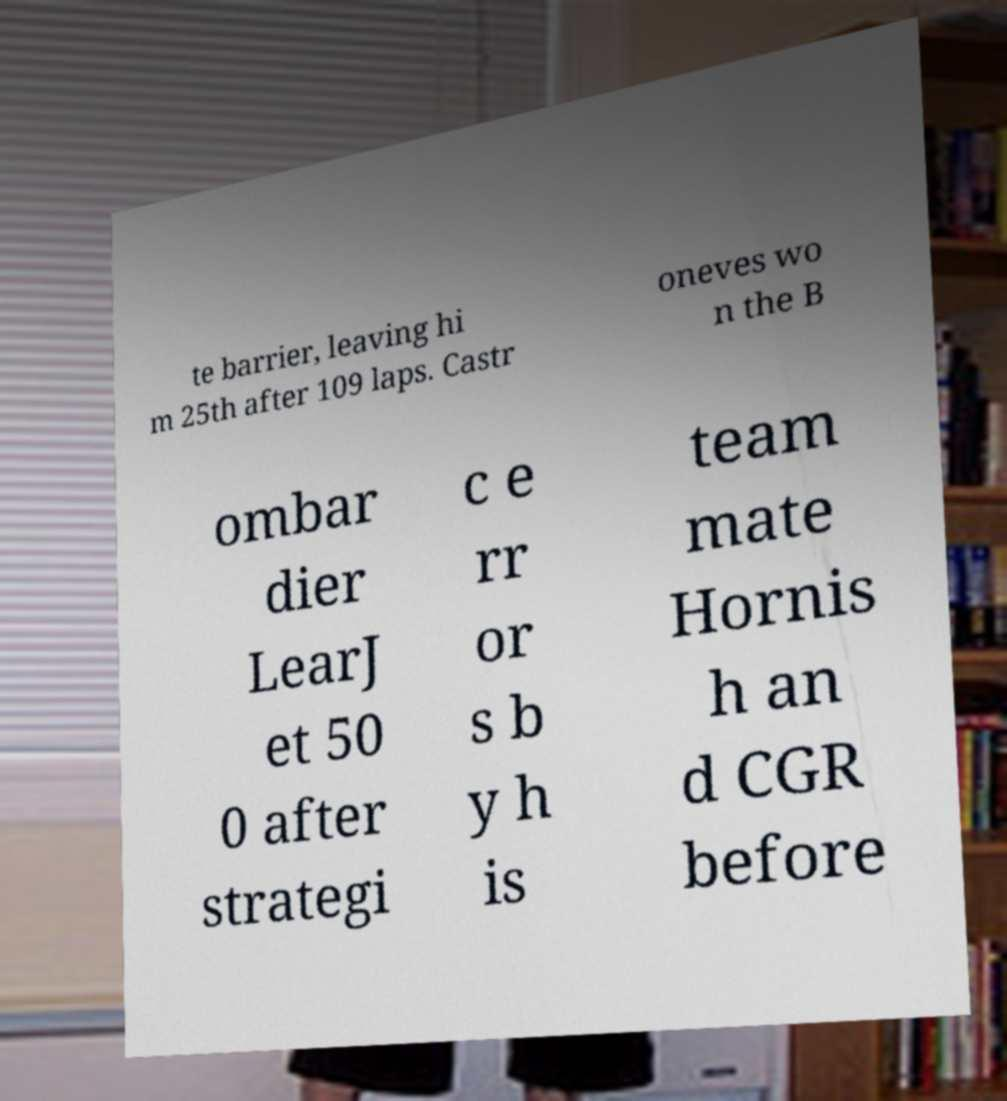I need the written content from this picture converted into text. Can you do that? te barrier, leaving hi m 25th after 109 laps. Castr oneves wo n the B ombar dier LearJ et 50 0 after strategi c e rr or s b y h is team mate Hornis h an d CGR before 